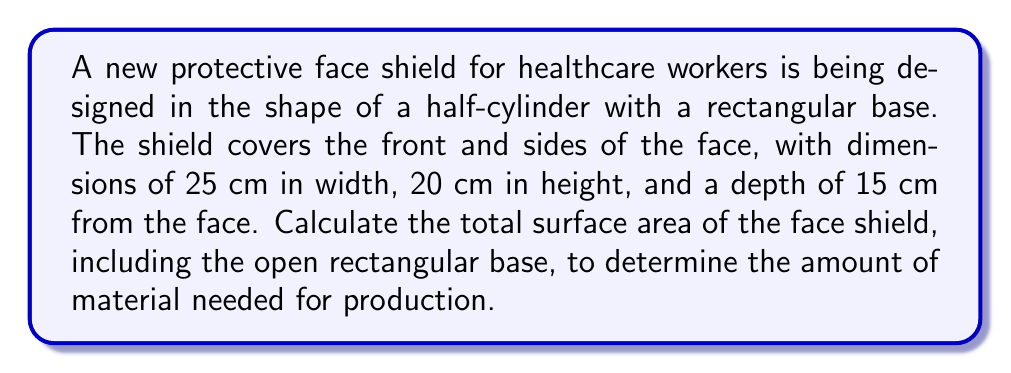Give your solution to this math problem. To solve this problem, we need to calculate the surface area of a half-cylinder plus the area of its rectangular base. Let's break it down step by step:

1. Dimensions:
   Width (w) = 25 cm
   Height (h) = 20 cm
   Depth (r) = 15 cm (this is the radius of the cylindrical part)

2. Calculate the area of the curved surface:
   The curved surface is half of a cylinder's lateral area.
   Lateral area of a full cylinder = $2\pi rh$
   Curved surface area = $\frac{1}{2} \cdot 2\pi rh = \pi rh$
   $$A_{curved} = \pi \cdot 15 \cdot 20 = 300\pi \text{ cm}^2$$

3. Calculate the area of the rectangular base:
   $$A_{base} = w \cdot h = 25 \cdot 20 = 500 \text{ cm}^2$$

4. Calculate the area of the rectangular sides:
   There are two rectangular sides, each with dimensions of depth (r) and height (h).
   $$A_{sides} = 2 \cdot r \cdot h = 2 \cdot 15 \cdot 20 = 600 \text{ cm}^2$$

5. Sum up all the areas to get the total surface area:
   $$A_{total} = A_{curved} + A_{base} + A_{sides}$$
   $$A_{total} = 300\pi + 500 + 600 \text{ cm}^2$$
   $$A_{total} = 300\pi + 1100 \text{ cm}^2$$

6. Simplify:
   $$A_{total} = 300\pi + 1100 \approx 2042.04 \text{ cm}^2$$

[asy]
import three;

size(200);
currentprojection=perspective(6,3,2);

path3 p=plane(6,4);
draw(surface(p),white);
draw(p);

triple A=(0,0,0), B=(6,0,0), C=(6,4,0), D=(0,4,0);
triple E=(0,0,3), F=(6,0,3), G=(6,4,3), H=(0,4,3);

draw(A--B--C--D--cycle);
draw(E--F--G--H--cycle);
draw(A--E);
draw(B--F);
draw(C--G);
draw(D--H);

draw(arc(C,G,E),dashed);
draw(arc(D,H,F),dashed);

label("25 cm",0.5(A+B),S);
label("20 cm",0.5(B+C),E);
label("15 cm",0.5(C+G),N);
[/asy]
Answer: The total surface area of the protective face shield is approximately 2042.04 cm². 